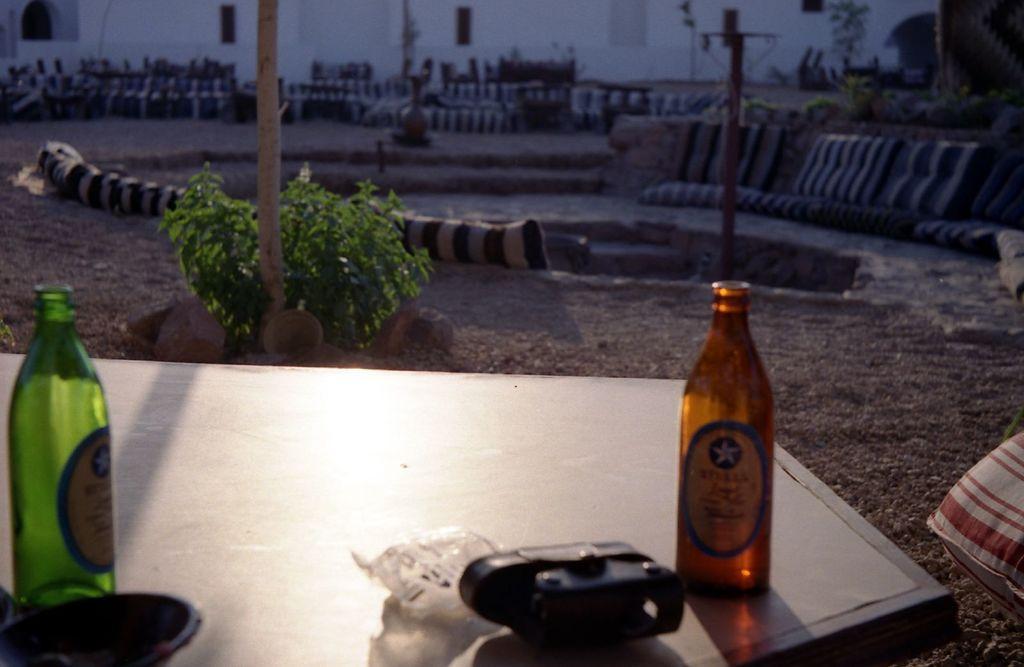Describe this image in one or two sentences. At the bottom of the image there is a table and we can see bottles and some objects placed on the table. In the background there are cushions, plants, poles and a wall. 